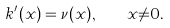Convert formula to latex. <formula><loc_0><loc_0><loc_500><loc_500>k ^ { \prime } ( x ) = \nu ( x ) , \quad x { \ne } 0 .</formula> 